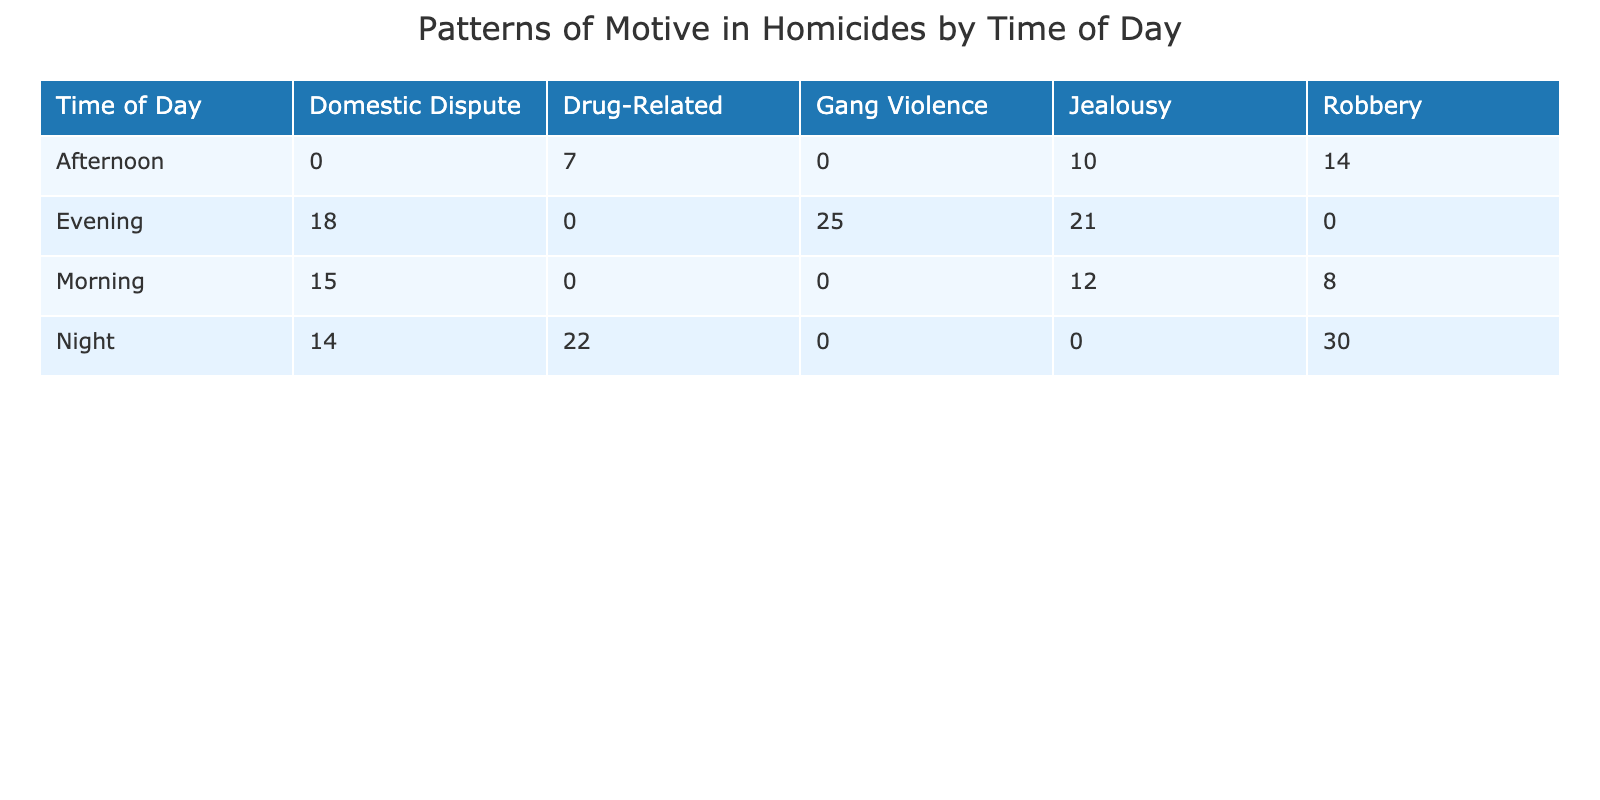What is the number of homicides motivated by jealousy during the evening? According to the table, the number of homicides motivated by jealousy specifically during the evening is listed directly in the corresponding row under the "Evening" time slot. It shows 21 homicides.
Answer: 21 How many homicides were reported in total for the morning? To find the total number of homicides in the morning, we sum the number of homicides in all motives listed under the "Morning" time slot: 12 (Jealousy) + 8 (Robbery) + 15 (Domestic Dispute) = 35.
Answer: 35 Is the number of drug-related homicides higher at night than in the afternoon? From the table, we see that drug-related homicides at night are 22, while in the afternoon, it is 7. Since 22 is greater than 7, the statement is true.
Answer: Yes What is the combined total of homicides motivated by robbery across all times of day? To calculate the total homicides motivated by robbery, we take each robbery value from the table: 8 (Morning) + 14 (Afternoon) + 30 (Night) = 52.
Answer: 52 Does domestic dispute have the highest number of homicides in any time period? Analyzing the table, we see that domestic dispute has the highest number of homicides in the evening (18), but that is not higher than gang violence (25) also in the evening. Therefore, domestic dispute is not the highest overall.
Answer: No What is the average number of homicides motivated by jealousy across all times of day? To find the average, we first sum the jealousy homicides: 12 (Morning) + 10 (Afternoon) + 21 (Evening) = 43. With 3 time categories, the average is 43 / 3 = approximately 14.33.
Answer: 14.33 Which motive had the least number of homicides reported during the afternoon? From the table's afternoon data, the motives listed with their numbers are Jealousy (10), Robbery (14), and Drug-Related (7). The motive with the least number is Drug-Related, with only 7 homicides.
Answer: Drug-Related What is the difference in the number of homicides caused by robbery at night compared to the evening? The number of homicides caused by robbery at night is 30, and during the evening, it is 0 (as there is no robbery motive listed for the evening). The difference is 30 - 0 = 30.
Answer: 30 How many more gang violence homicides were there compared to jealousy homicides in the evening? In the evening, gang violence has 25 homicides and jealousy has 21. The difference is calculated as 25 - 21 = 4, meaning there are 4 more homicides caused by gang violence than jealousy.
Answer: 4 